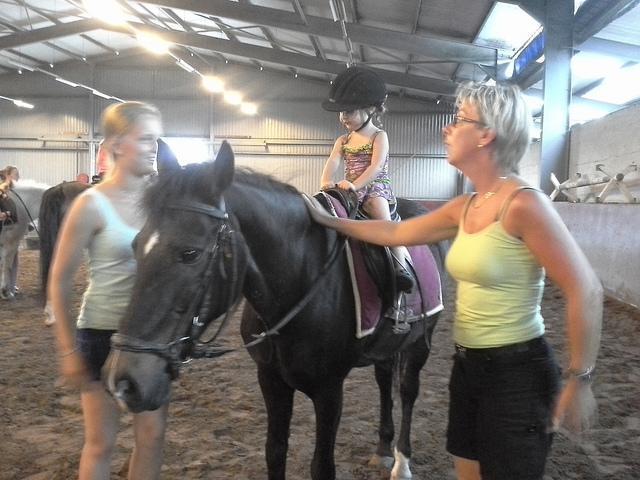How many horses are there?
Give a very brief answer. 3. How many people are there?
Give a very brief answer. 4. How many clock faces are on the tower?
Give a very brief answer. 0. 